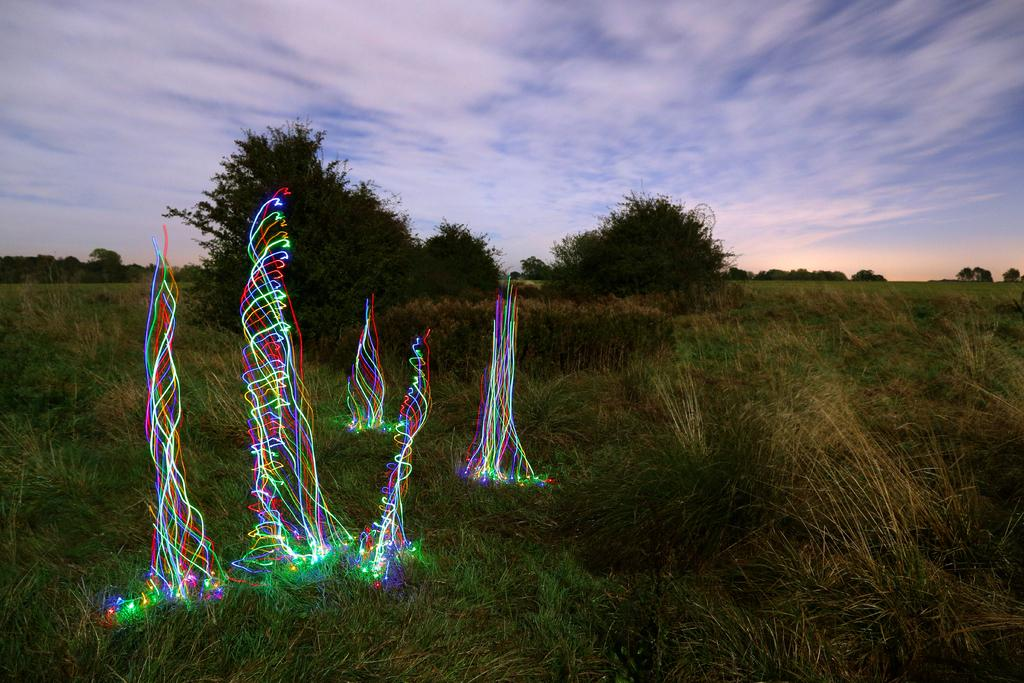What type of surface is visible in the image? There is ground visible in the image. What type of vegetation is present on the ground? There is grass on the ground. What type of illumination can be seen in the image? There are colorful lights in the image. What type of natural elements are present in the image? There are trees in the image. What is visible in the background of the image? The sky is visible in the background of the image. Where is the alley located in the image? There is no alley present in the image. What type of toothpaste is used to clean the colorful lights in the image? There is no toothpaste mentioned or implied in the image; the colorful lights are not being cleaned. 